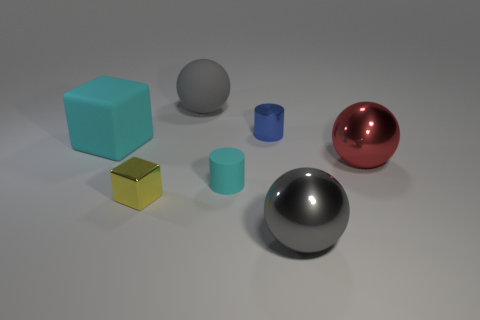Add 1 green rubber cylinders. How many objects exist? 8 Subtract all cubes. How many objects are left? 5 Subtract 0 blue blocks. How many objects are left? 7 Subtract all yellow metallic things. Subtract all tiny metallic cubes. How many objects are left? 5 Add 6 big metallic objects. How many big metallic objects are left? 8 Add 3 tiny green objects. How many tiny green objects exist? 3 